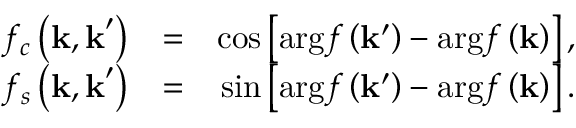Convert formula to latex. <formula><loc_0><loc_0><loc_500><loc_500>\begin{array} { r l r } { f _ { c } \left ( k , k ^ { \prime } \right ) } & { = } & { \cos \left [ \arg f \left ( k ^ { \prime } \right ) - \arg f \left ( k \right ) \right ] , } \\ { f _ { s } \left ( k , k ^ { \prime } \right ) } & { = } & { \sin \left [ \arg f \left ( k ^ { \prime } \right ) - \arg f \left ( k \right ) \right ] . } \end{array}</formula> 